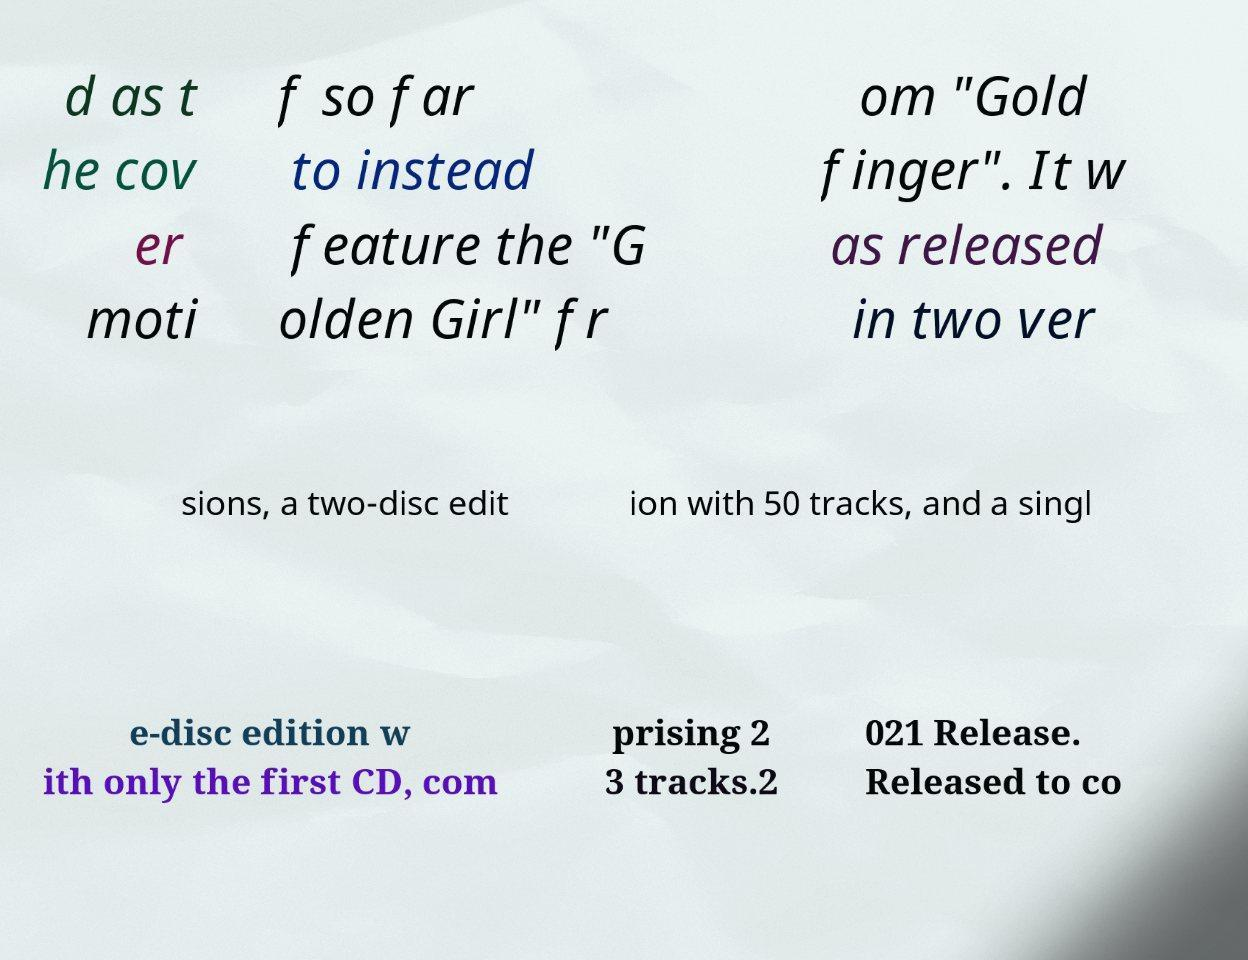There's text embedded in this image that I need extracted. Can you transcribe it verbatim? d as t he cov er moti f so far to instead feature the "G olden Girl" fr om "Gold finger". It w as released in two ver sions, a two-disc edit ion with 50 tracks, and a singl e-disc edition w ith only the first CD, com prising 2 3 tracks.2 021 Release. Released to co 